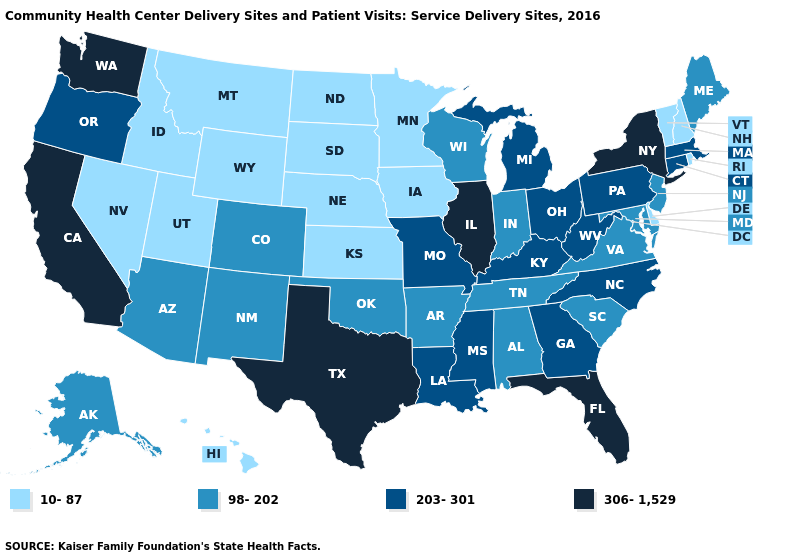Does Oklahoma have a lower value than Mississippi?
Answer briefly. Yes. Name the states that have a value in the range 98-202?
Be succinct. Alabama, Alaska, Arizona, Arkansas, Colorado, Indiana, Maine, Maryland, New Jersey, New Mexico, Oklahoma, South Carolina, Tennessee, Virginia, Wisconsin. Among the states that border Utah , which have the lowest value?
Give a very brief answer. Idaho, Nevada, Wyoming. What is the value of Mississippi?
Short answer required. 203-301. Name the states that have a value in the range 306-1,529?
Write a very short answer. California, Florida, Illinois, New York, Texas, Washington. Name the states that have a value in the range 306-1,529?
Answer briefly. California, Florida, Illinois, New York, Texas, Washington. What is the lowest value in the USA?
Be succinct. 10-87. Does Delaware have the lowest value in the South?
Short answer required. Yes. Name the states that have a value in the range 306-1,529?
Answer briefly. California, Florida, Illinois, New York, Texas, Washington. Name the states that have a value in the range 203-301?
Keep it brief. Connecticut, Georgia, Kentucky, Louisiana, Massachusetts, Michigan, Mississippi, Missouri, North Carolina, Ohio, Oregon, Pennsylvania, West Virginia. What is the value of Texas?
Short answer required. 306-1,529. Among the states that border Kentucky , which have the lowest value?
Concise answer only. Indiana, Tennessee, Virginia. Name the states that have a value in the range 10-87?
Concise answer only. Delaware, Hawaii, Idaho, Iowa, Kansas, Minnesota, Montana, Nebraska, Nevada, New Hampshire, North Dakota, Rhode Island, South Dakota, Utah, Vermont, Wyoming. What is the value of Kentucky?
Give a very brief answer. 203-301. What is the value of Indiana?
Answer briefly. 98-202. 